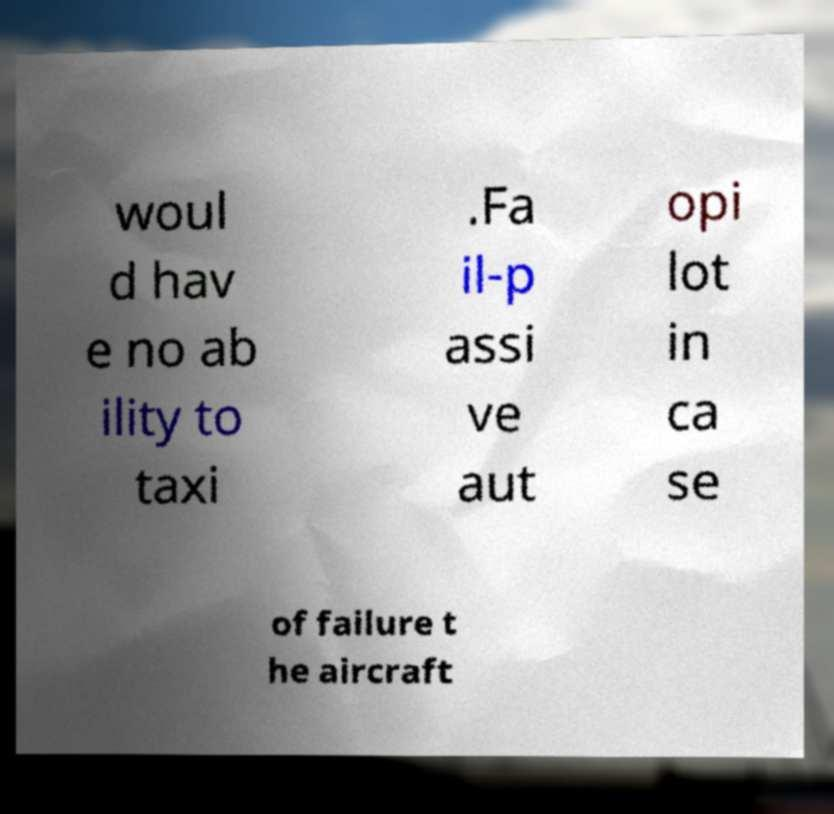Please read and relay the text visible in this image. What does it say? woul d hav e no ab ility to taxi .Fa il-p assi ve aut opi lot in ca se of failure t he aircraft 